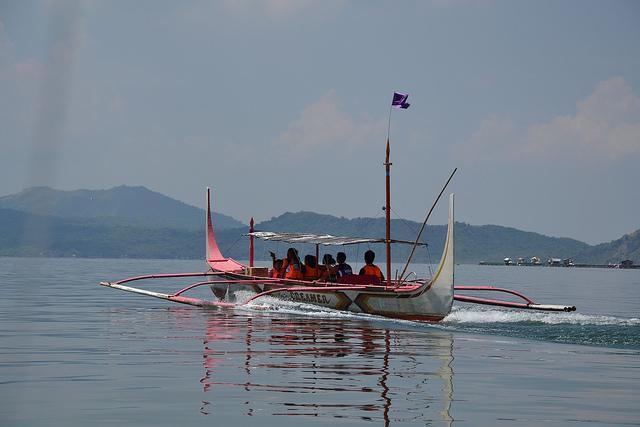How many surfboards are shown?
Give a very brief answer. 0. 